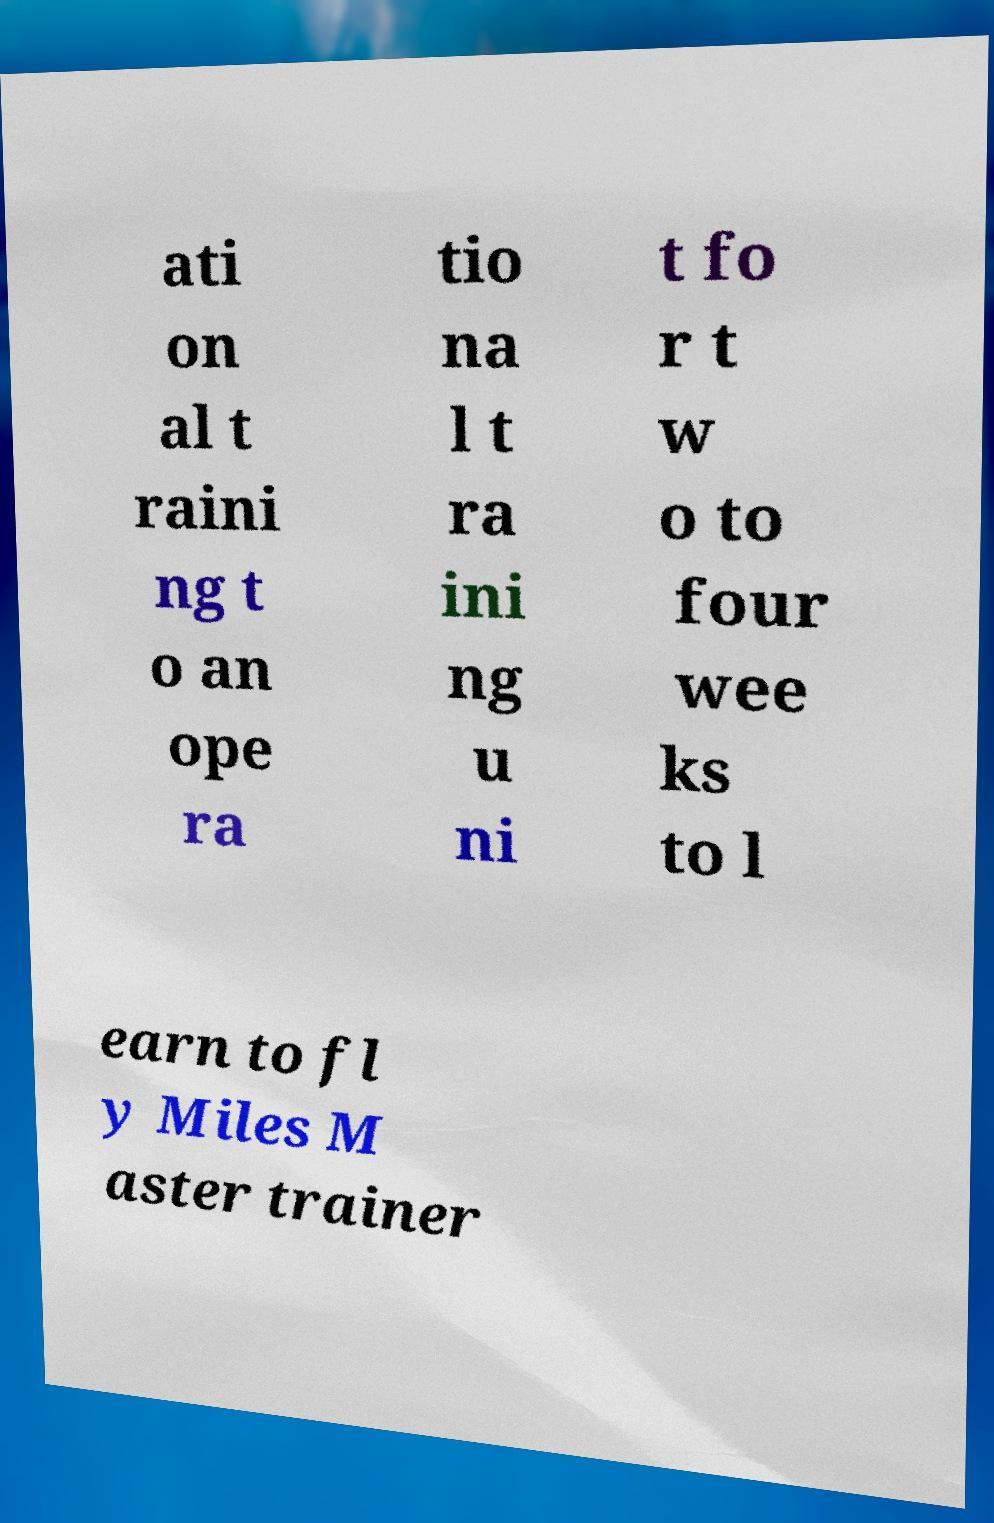Could you extract and type out the text from this image? ati on al t raini ng t o an ope ra tio na l t ra ini ng u ni t fo r t w o to four wee ks to l earn to fl y Miles M aster trainer 